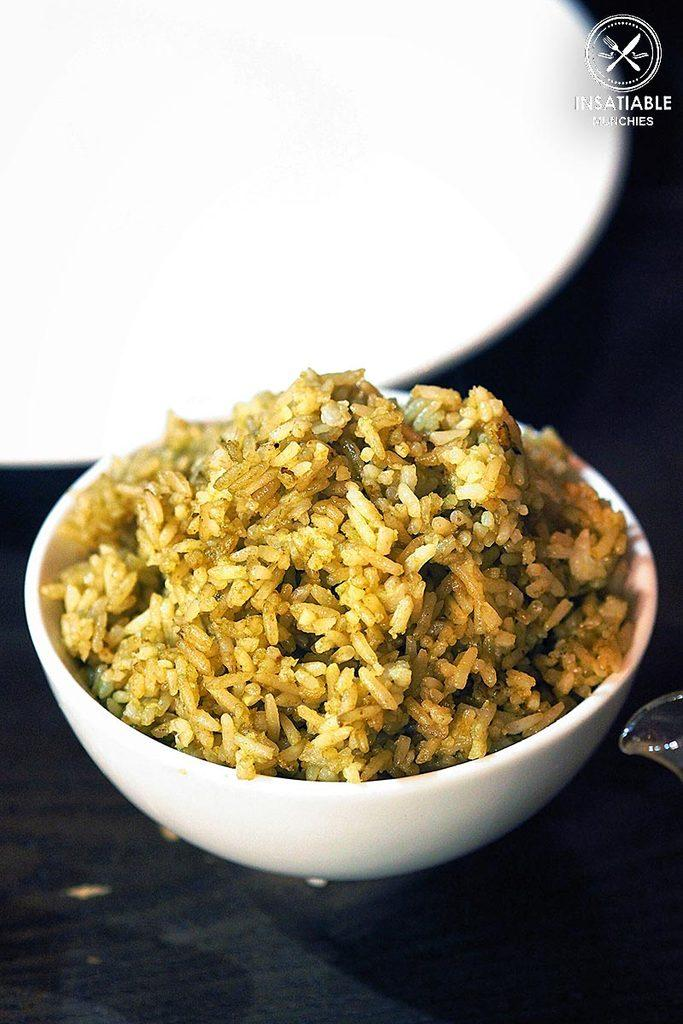What is in the bowl that is visible in the image? There is a bowl containing food in the image. Where is the bowl placed in the image? The bowl is placed on a surface. Can you describe any other bowls or plates in the image? There is a bowl and a plate in the background of the image. What else can be seen in the background of the image? There is a logo with some text in the background of the image. Reasoning: Let's think step by identifying the main subjects and objects in the image based on the provided facts. We then formulate questions that focus on the location and characteristics of these subjects and objects, ensuring that each question can be answered definitively with the information given. We avoid yes/no questions and ensure that the language is simple and clear. Absurd Question/Answer: What type of base is supporting the table in the image? There is no table present in the image, only a bowl containing food and a surface on which it is placed. How many adjustments were made to the plate in the image? There is no mention of adjustments being made to the plate in the image, as it is simply present in the background. What type of base is supporting the table in the image? There is no table present in the image, only a bowl containing food and a surface on which it is placed. How many adjustments were made to the plate in the image? There is no mention of adjustments being made to the plate in the image, as it is simply present in the background. 